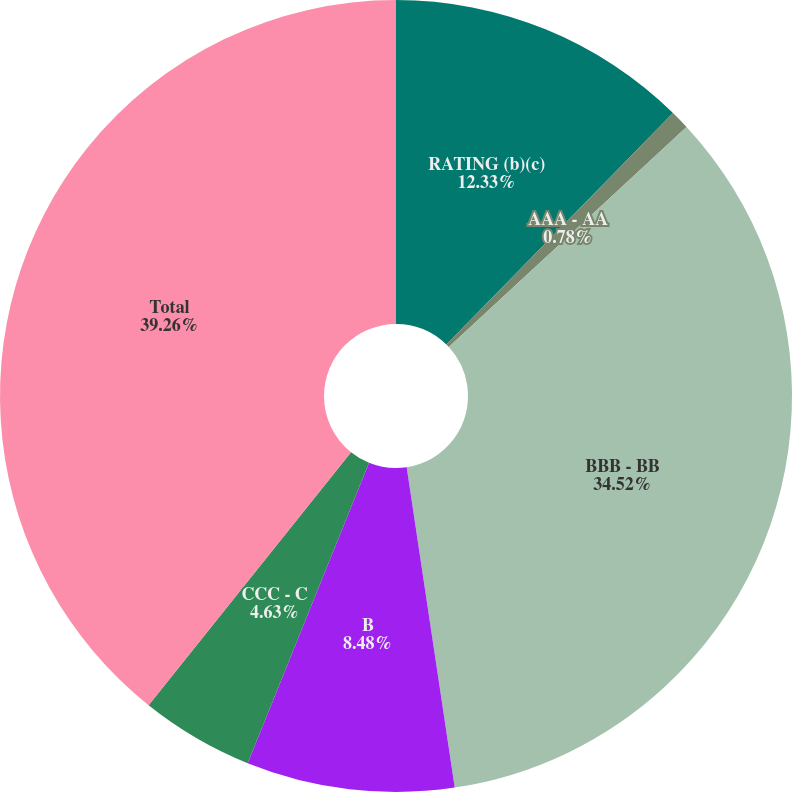Convert chart. <chart><loc_0><loc_0><loc_500><loc_500><pie_chart><fcel>RATING (b)(c)<fcel>AAA - AA<fcel>BBB - BB<fcel>B<fcel>CCC - C<fcel>Total<nl><fcel>12.33%<fcel>0.78%<fcel>34.52%<fcel>8.48%<fcel>4.63%<fcel>39.26%<nl></chart> 